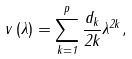<formula> <loc_0><loc_0><loc_500><loc_500>v \left ( \lambda \right ) = \sum _ { k = 1 } ^ { p } \frac { d _ { k } } { 2 k } \lambda ^ { 2 k } ,</formula> 